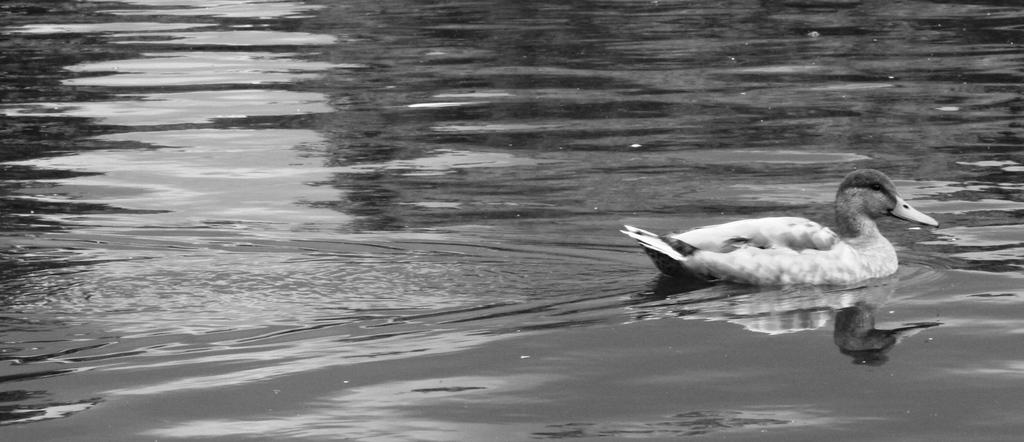What is the color scheme of the image? The image is black and white. What is the main subject of the image? There is a picture of a bird in the image. Where is the bird located in the image? The bird is in the water. What is the name of the daughter in the image? There is no daughter present in the image; it features a picture of a bird in the water. What time of day is depicted in the image? The image is black and white, so it is not possible to determine the time of day from the image. 